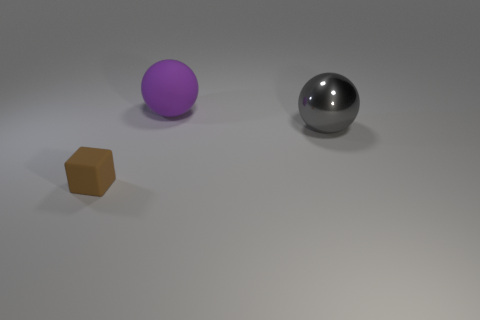What shape is the matte object that is behind the thing left of the matte thing on the right side of the tiny block?
Offer a very short reply. Sphere. What number of other things are there of the same shape as the brown matte object?
Keep it short and to the point. 0. What number of metal objects are either big balls or large purple things?
Your answer should be very brief. 1. There is a sphere that is right of the ball that is behind the large gray ball; what is it made of?
Keep it short and to the point. Metal. Are there more tiny blocks that are to the left of the gray metal thing than purple rubber things?
Make the answer very short. No. Is there a large ball that has the same material as the big purple thing?
Provide a short and direct response. No. Do the big thing that is to the right of the purple rubber object and the tiny object have the same shape?
Provide a succinct answer. No. There is a big thing in front of the big object that is behind the gray sphere; what number of tiny matte blocks are behind it?
Your response must be concise. 0. Are there fewer big purple matte spheres on the left side of the big purple rubber thing than large metal things left of the tiny matte cube?
Keep it short and to the point. No. There is another large metallic thing that is the same shape as the purple object; what is its color?
Offer a very short reply. Gray. 